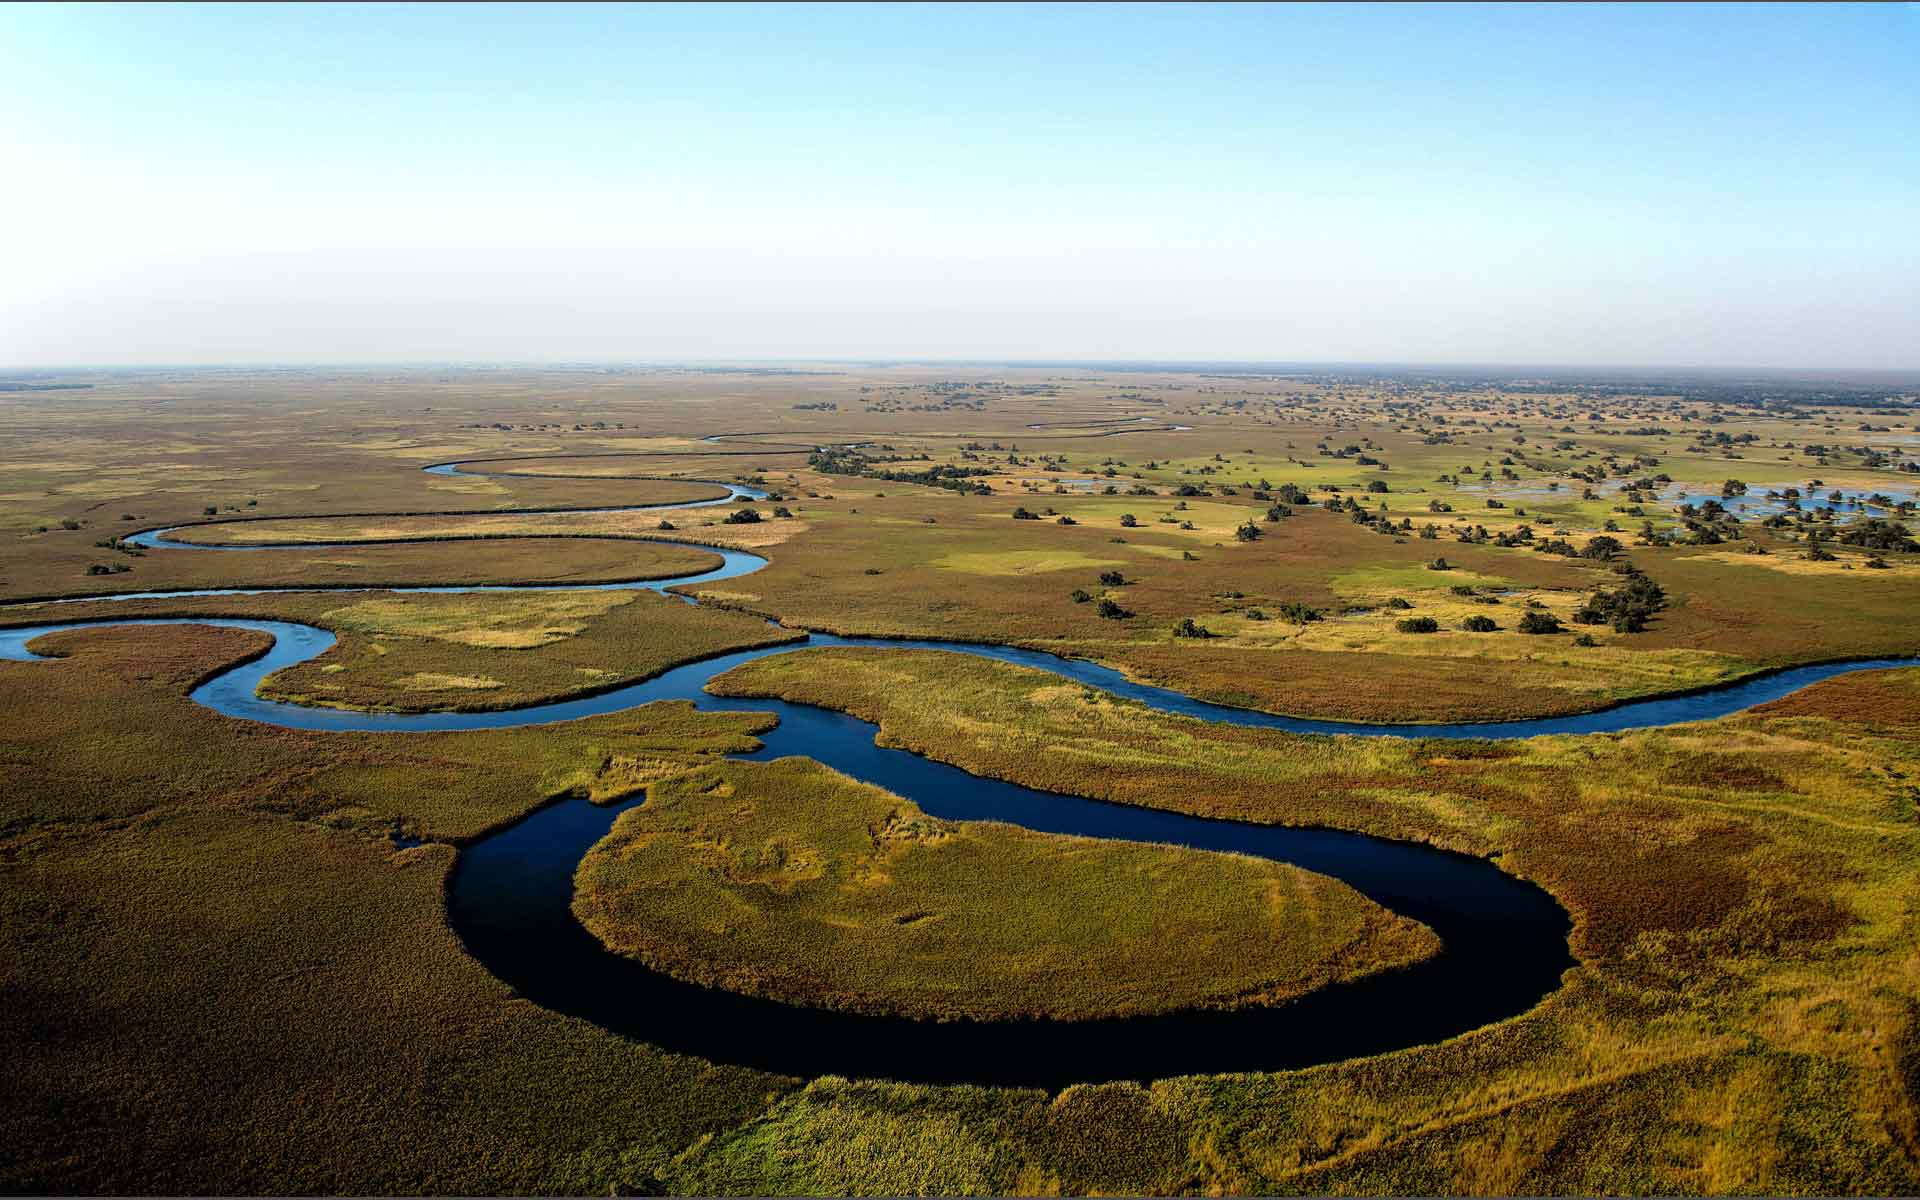How does the annual flooding cycle affect the landscape and wildlife of the Okavango Delta? The annual flooding cycle of the Okavango Delta, primarily influenced by seasonal rainfall in the Angolan highlands, revitalizes the region each year. As the floodwaters spread across the delta, they bring essential nutrients that enrich the soil, supporting lush vegetation growth. This in turn sustains a rich variety of herbivores and the predators that follow. The water also creates temporary islands and provides critical breeding sites for fish and birds. This cycle of renewal ensures the survival of the delta's diverse ecosystems, making it a crucial ecological sanctuary. 